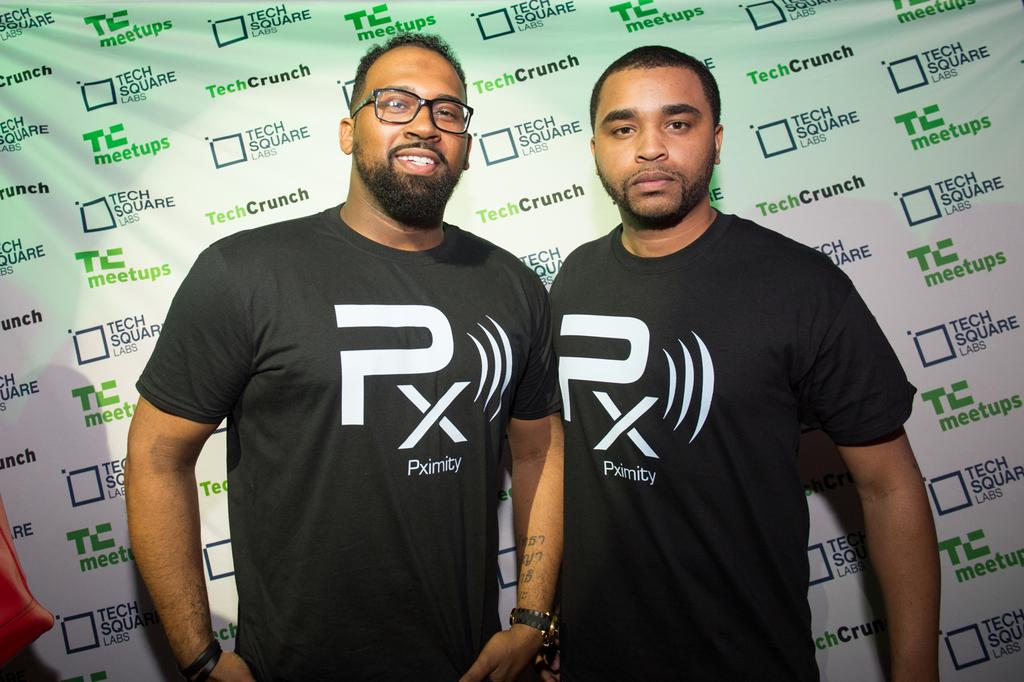How many people are in the image? There are two persons standing in the image. Can you describe the appearance of the person on the left side? The person on the left side is wearing spectacles. What is visible behind the two persons? There is a banner visible behind the two persons. What can be seen at the left bottom of the image? There is an object located at the left bottom of the image. How many spiders are crawling on the banner in the image? There are no spiders visible in the image, and therefore no spiders can be seen crawling on the banner. What type of brake is present on the object at the left bottom of the image? There is no brake present in the image, as the object at the left bottom of the image is not described in the facts. 